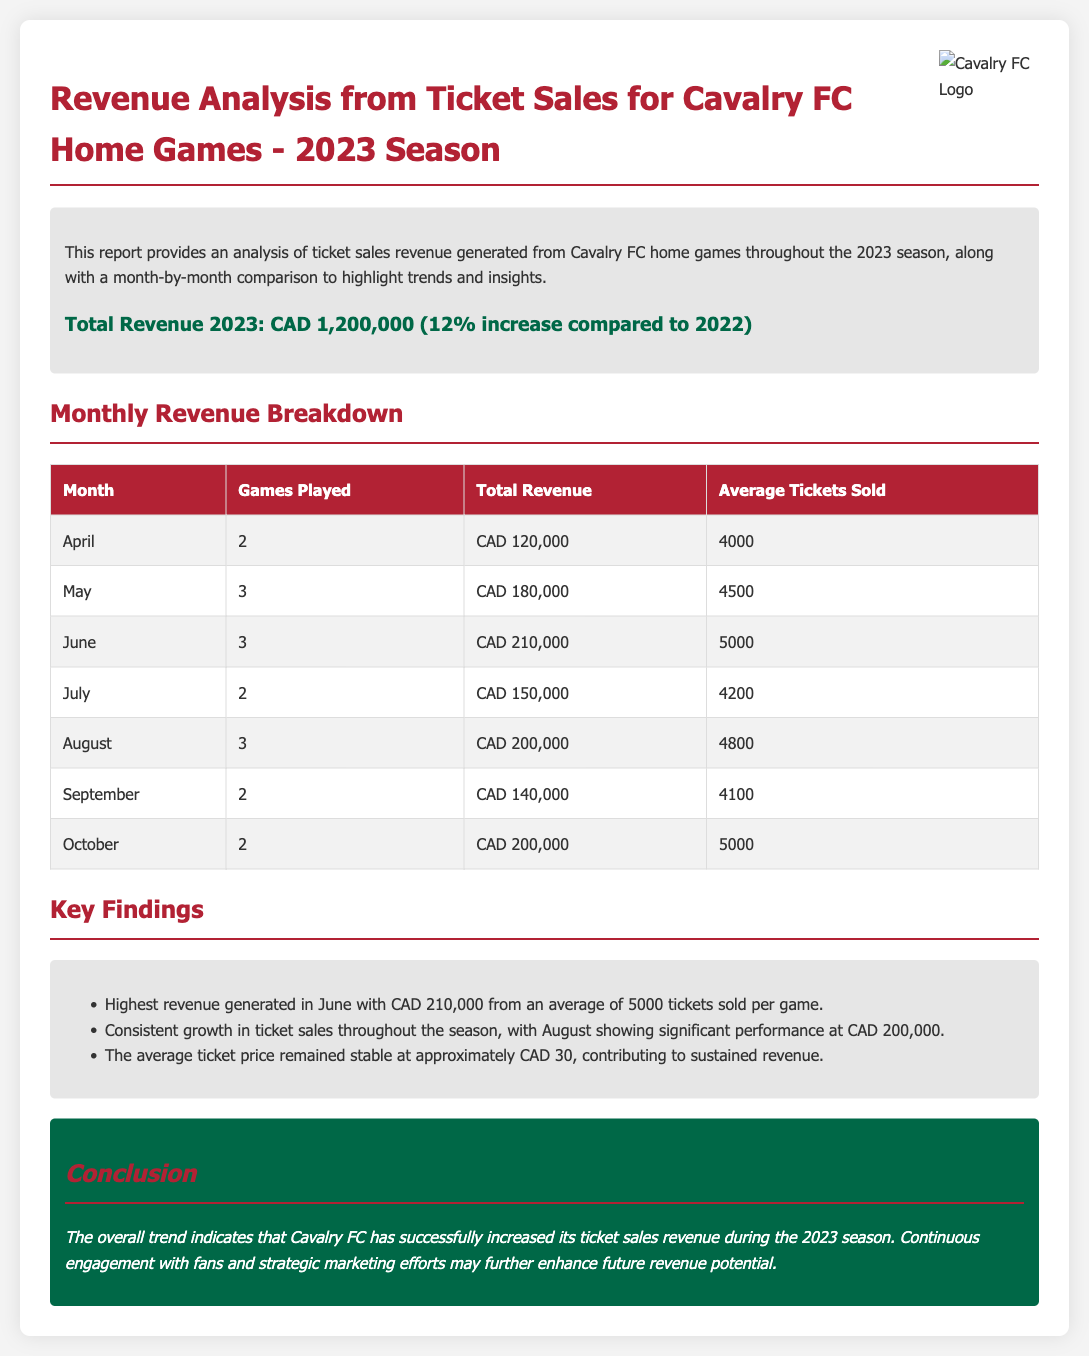What is the total revenue for the 2023 season? The total revenue is stated in the summary as CAD 1,200,000, which is a 12% increase compared to 2022.
Answer: CAD 1,200,000 Which month had the highest revenue? The key findings section highlights that June generated the highest revenue of CAD 210,000.
Answer: June How many games were played in May? The monthly revenue breakdown table indicates that 3 games were played in May.
Answer: 3 What was the average ticket price? The key findings mention that the average ticket price remained stable at approximately CAD 30.
Answer: CAD 30 What was the total revenue for August? The monthly revenue breakdown states that the total revenue for August was CAD 200,000.
Answer: CAD 200,000 Which month had only 2 games played? Looking at the monthly revenue breakdown table, July and September both had only 2 games played.
Answer: July, September What was the average tickets sold in June? The monthly revenue breakdown shows that an average of 5000 tickets were sold per game in June.
Answer: 5000 What is the key takeaway from the conclusion? The conclusion summarizes that Cavalry FC has successfully increased its ticket sales revenue during the 2023 season.
Answer: Increased ticket sales revenue 